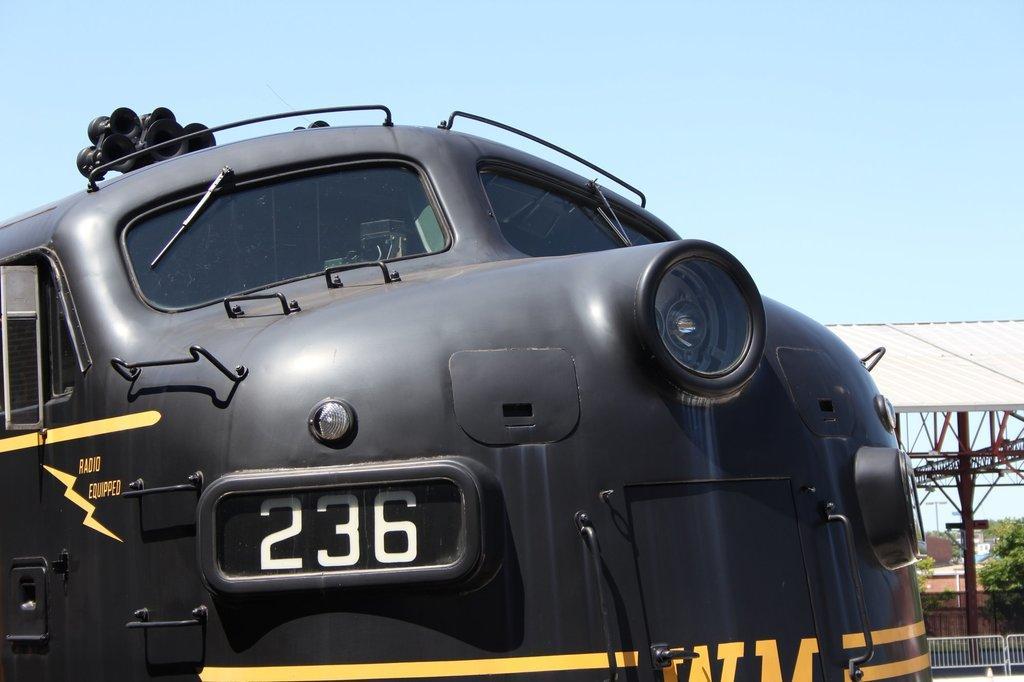Describe this image in one or two sentences. In this image I can see a vehicle which is black, yellow and white in color. I can see two wipers and a headlight. In the background I can see a shed, the railing, few trees, few buildings and the sky. 